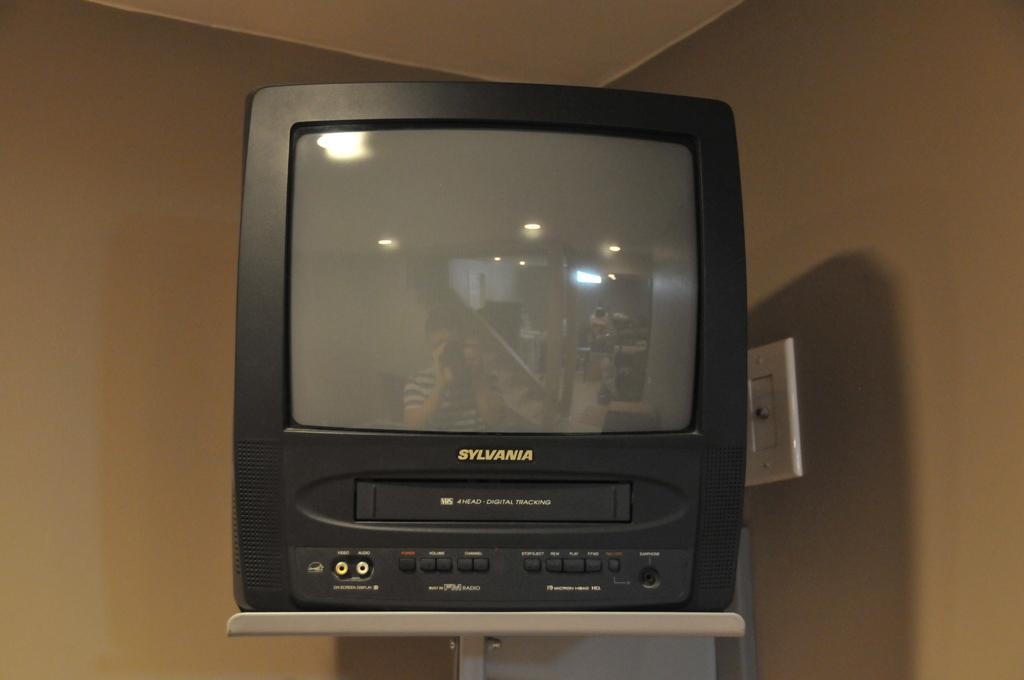<image>
Summarize the visual content of the image. A person reflected in the screen of a small wall-mounted Sylvania television. 